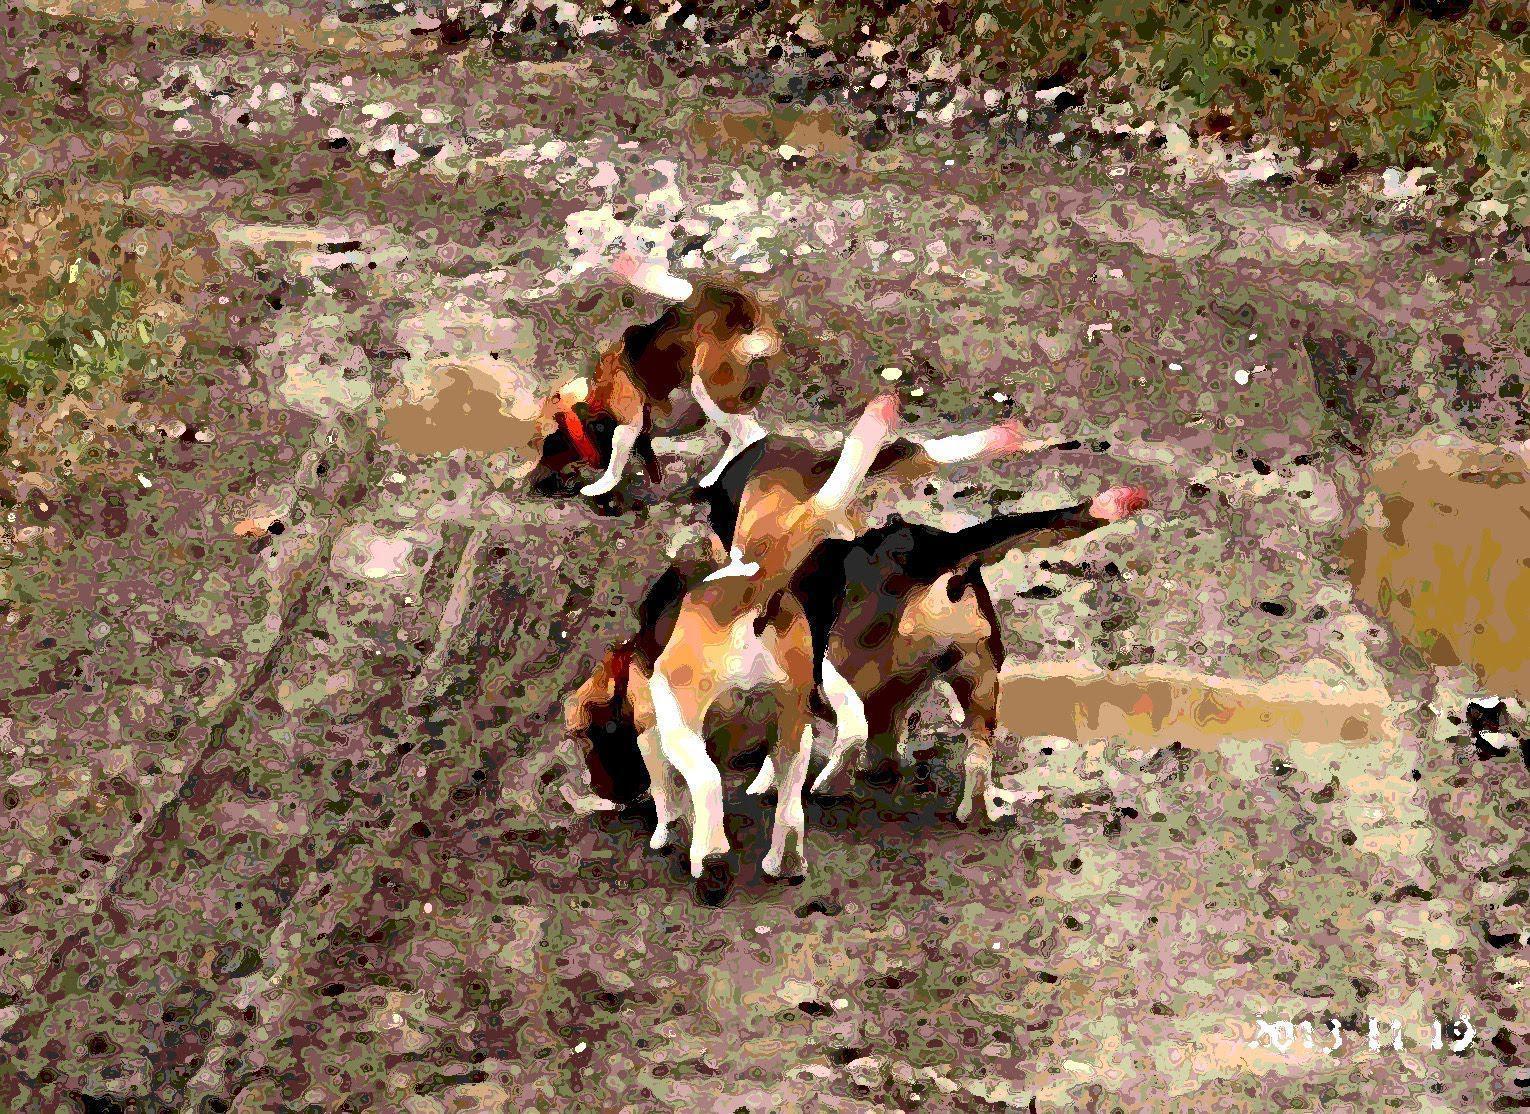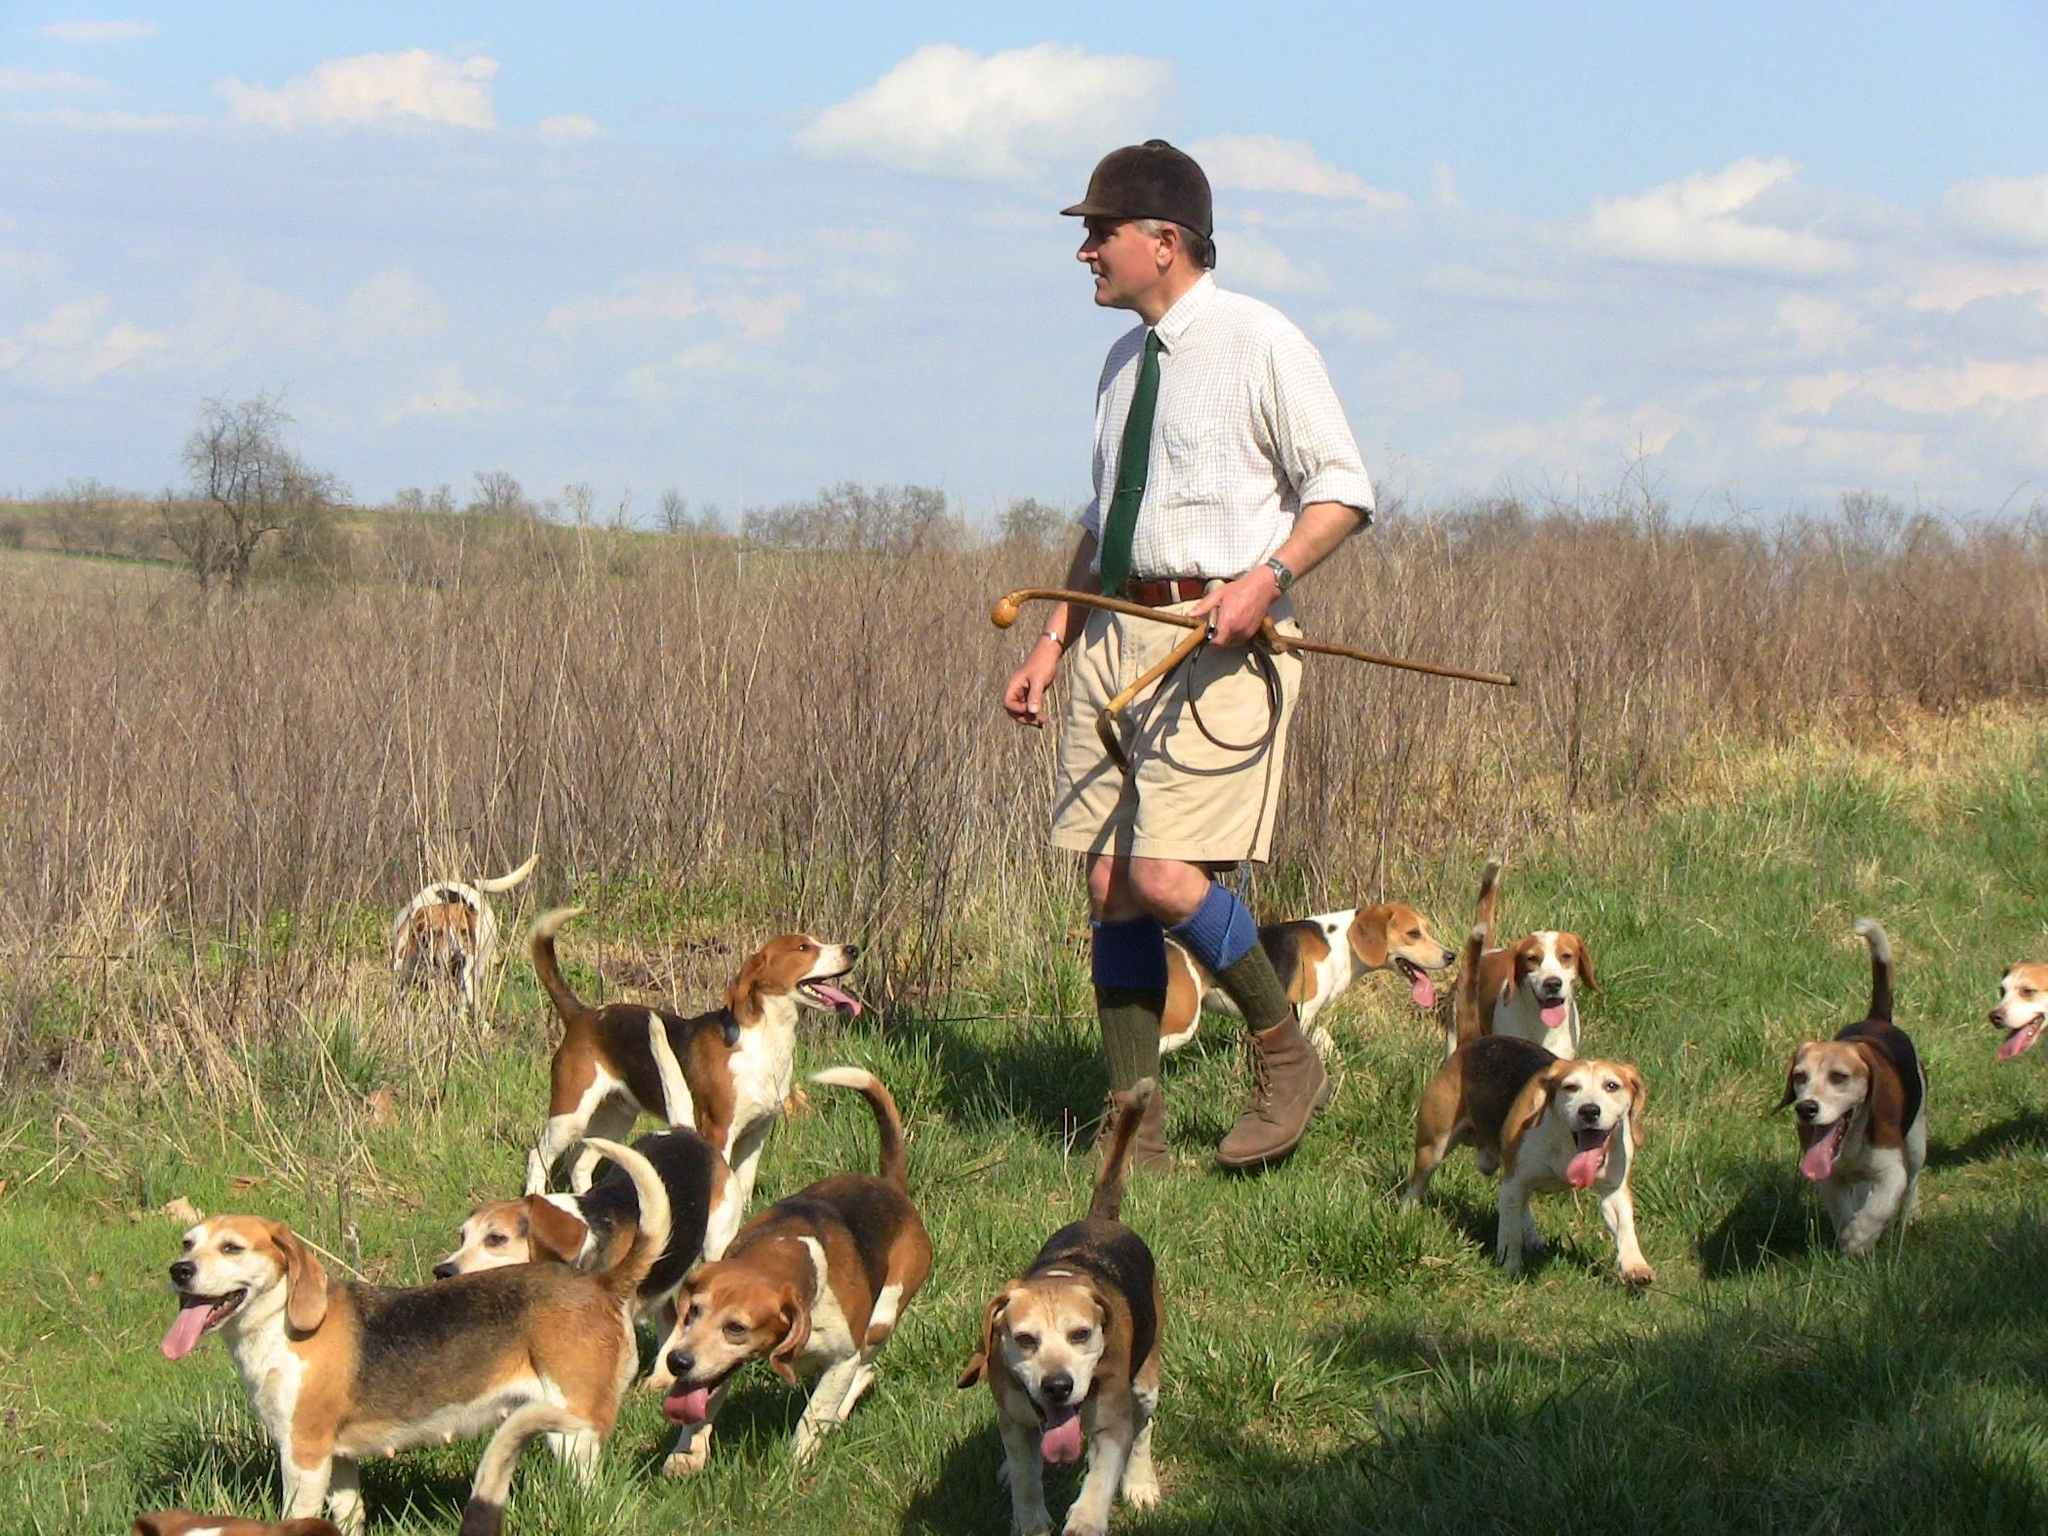The first image is the image on the left, the second image is the image on the right. For the images shown, is this caption "There is a single person standing with a group of dogs in one of the images." true? Answer yes or no. Yes. The first image is the image on the left, the second image is the image on the right. Considering the images on both sides, is "At least one of the images shows only one dog." valid? Answer yes or no. No. The first image is the image on the left, the second image is the image on the right. Assess this claim about the two images: "At least one of the images contains one or more rabbits.". Correct or not? Answer yes or no. No. The first image is the image on the left, the second image is the image on the right. Examine the images to the left and right. Is the description "1 dog has a tail that is sticking up." accurate? Answer yes or no. No. 